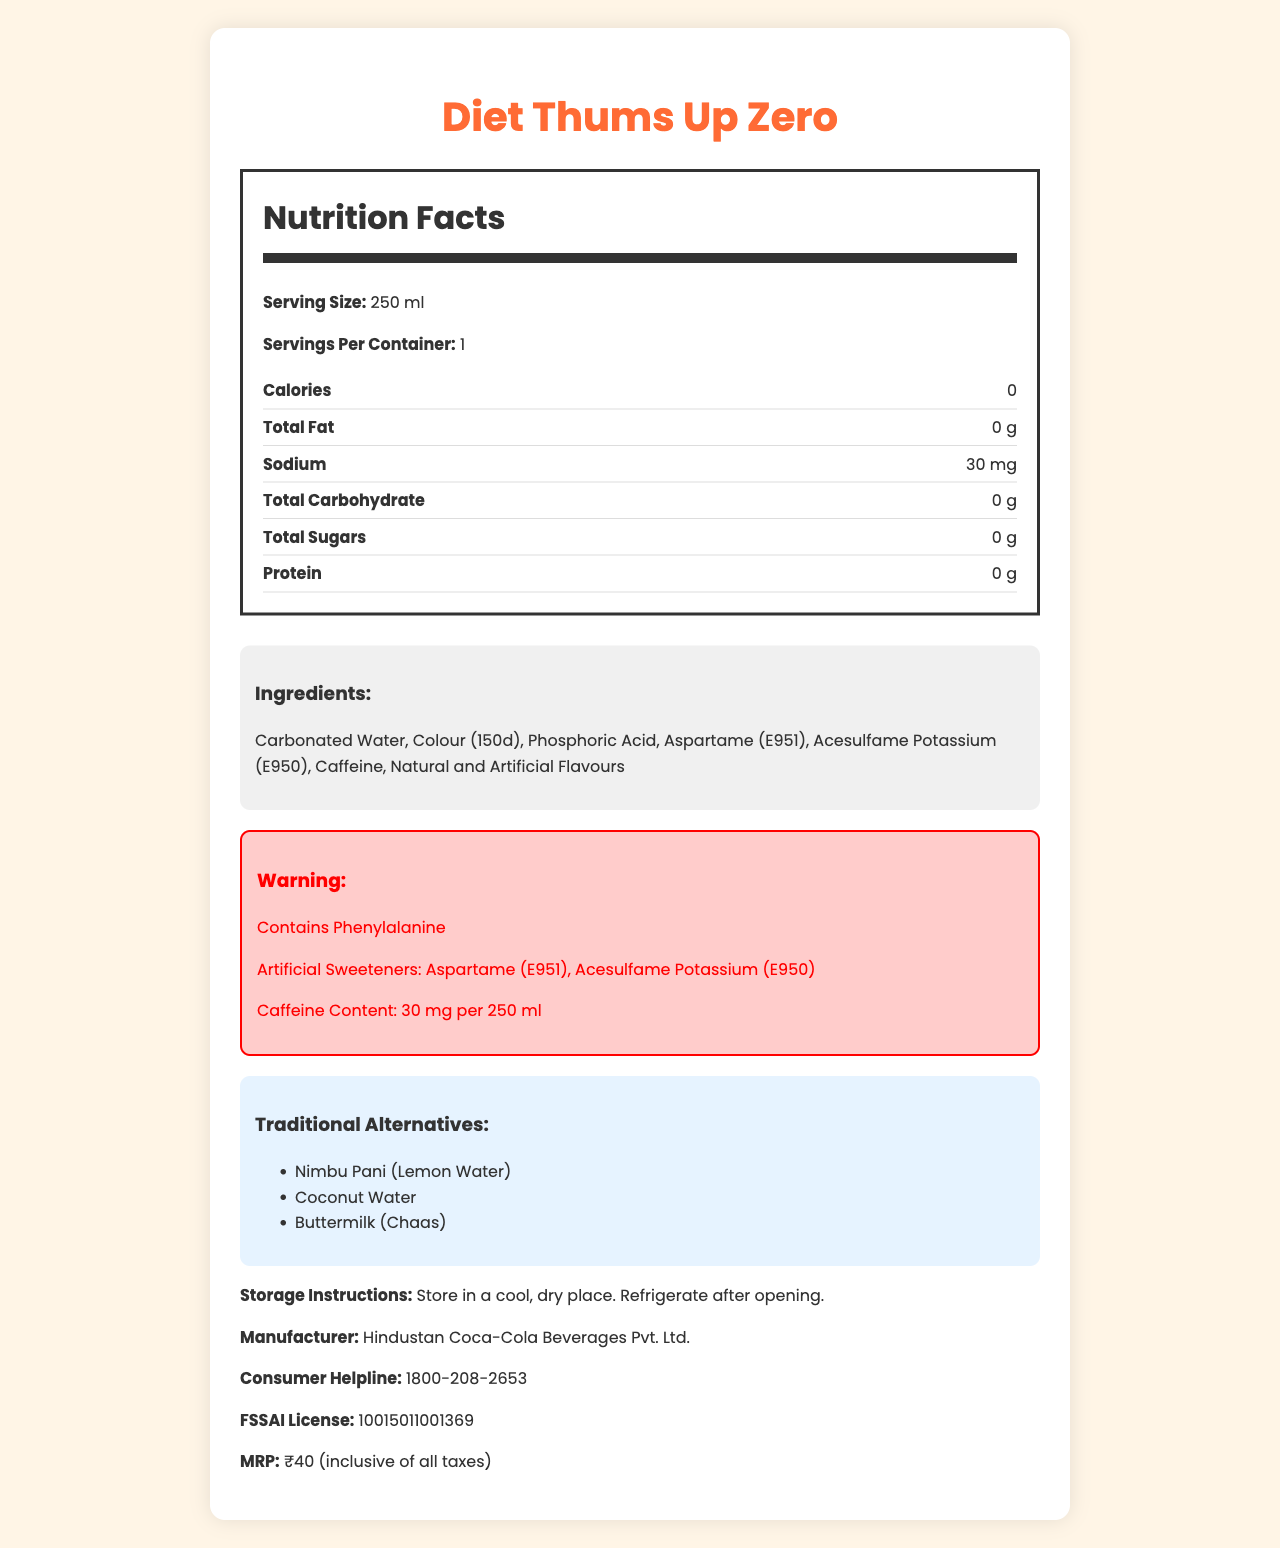what is the serving size of Diet Thums Up Zero? The document explicitly states that the serving size is 250 ml.
Answer: 250 ml how much sodium is in one serving? The Nutrition Facts section lists sodium content as 30 mg per serving.
Answer: 30 mg does Diet Thums Up Zero contain any sugar? The Nutrition Facts section shows 0 g of total sugars and 0 g of added sugars.
Answer: No what are the artificial sweeteners used in Diet Thums Up Zero? The document lists Aspartame (E951) and Acesulfame Potassium (E950) as artificial sweeteners in the ingredients section.
Answer: Aspartame (E951), Acesulfame Potassium (E950) what is the main benefit claimed by this product? The document mentions these claims in the suspicious claims section.
Answer: Zero calories, same great taste; Helps in weight management; No added sugar, perfect for diabetics which item is not part of the Nutrition Facts label? A. Total Fat B. Vitamin C C. Sodium D. Total Carbohydrate The document does not mention Vitamin C in the Nutrition Facts label.
Answer: B how many milligrams of caffeine are in a 250 ml serving? A. 20 mg B. 30 mg C. 40 mg D. 50 mg The document states that there are 30 mg of caffeine per 250 ml serving.
Answer: B which of these traditional alternatives is listed in the document? A. Buttermilk B. Sprite C. Orange Juice D. Ginger Ale The document lists Buttermilk (Chaas) as one of the traditional alternatives.
Answer: A is the product suitable for people who are allergic to phenylalanine? The document contains a warning that mentions the presence of Phenylalanine.
Answer: No does the document list the FSSAI license number? The document lists the FSSAI license number as 10015011001369.
Answer: Yes summarize the main features and details of this document. The explanation incorporates key points from different sections of the document including the name, nutritional facts, ingredient details, warnings, and additional product information.
Answer: The document describes the Nutrition Facts for Diet Thums Up Zero, a diet version of a common Indian soft drink with artificial sweeteners. It provides nutritional information, such as zero calories, 30 mg of sodium, and 30 mg of caffeine per serving. The ingredients include carbonated water, phosphoric acid, and artificial sweeteners like Aspartame and Acesulfame Potassium. There are warnings about Phenylalanine and caffeine content. The document also lists traditional alternatives like Nimbu Pani and Buttermilk and includes storage instructions, manufacturer details, a consumer helpline, and the maximum retail price. what are the long-term effects of consuming artificial sweeteners? The document mentions that the long-term effects of artificial sweeteners are still debated, but does not provide definite information on this topic.
Answer: Cannot be determined 